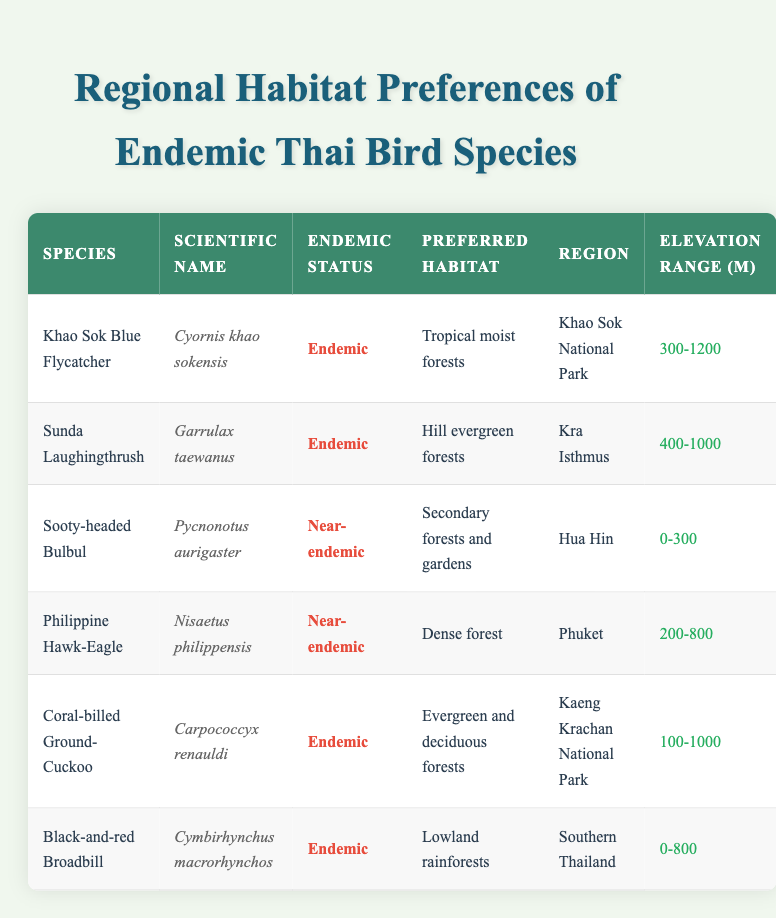What is the preferred habitat of the Khao Sok Blue Flycatcher? The table lists the preferred habitat of the Khao Sok Blue Flycatcher as "Tropical moist forests." This information can be found directly in the row corresponding to this species.
Answer: Tropical moist forests Which bird species has a preferred habitat in lowland rainforests? By scanning the "Preferred Habitat" column, the row for the "Black-and-red Broadbill" indicates that its preferred habitat is "Lowland rainforests." I found this by locating the species in the table and checking its corresponding habitat information.
Answer: Black-and-red Broadbill Are there any near-endemic species listed in the table? In the "Endemic Status" column, both the Sooty-headed Bulbul and the Philippine Hawk-Eagle are marked as "Near-endemic." This indicates there are two near-endemic species in the table.
Answer: Yes What is the elevation range of the Coral-billed Ground-Cuckoo? The elevation range for the Coral-billed Ground-Cuckoo is specified in the table under the "Elevation Range (m)" column as "100-1000." I verified this by locating the specific entry for this species in the table.
Answer: 100-1000 Which region contains the Sunda Laughingthrush and what is its preferred habitat? The "Region" for the Sunda Laughingthrush is "Kra Isthmus," and its "Preferred Habitat" is identified as "Hill evergreen forests" in the table. To find this, I looked for the row for this species and read across to the relevant columns.
Answer: Kra Isthmus; Hill evergreen forests What is the total number of endemic bird species mentioned in the table? To solve this, I first counted all species marked as "Endemic" in the "Endemic Status" column. There are four endemic species listed: the Khao Sok Blue Flycatcher, Sunda Laughingthrush, Coral-billed Ground-Cuckoo, and Black-and-red Broadbill. Therefore, the total is four.
Answer: 4 What is the average elevation range of the endemic bird species in the table? First, I identified the elevation ranges for the four endemic species: "300-1200," "400-1000," "100-1000," and "0-800." I converted these ranges into numerical averages: (300+1200)/2 = 750, (400+1000)/2 = 700, (100+1000)/2 = 550, and (0+800)/2 = 400. Finally, I calculated the overall average elevation as (750 + 700 + 550 + 400) / 4 = 600.
Answer: 600 Which species is found in Hua Hin and what is its elevation range? By examining the table, I see that the Sooty-headed Bulbul is located in the region of Hua Hin, and its elevation range is "0-300." This information can be accessed directly by checking the row for this specific species.
Answer: Sooty-headed Bulbul; 0-300 Is the region for the Black-and-red Broadbill classified within Southern Thailand? The table includes "Southern Thailand" as the region for the Black-and-red Broadbill, confirming that this species is indeed found within that region. This can be readily checked in the corresponding row of the table.
Answer: Yes 